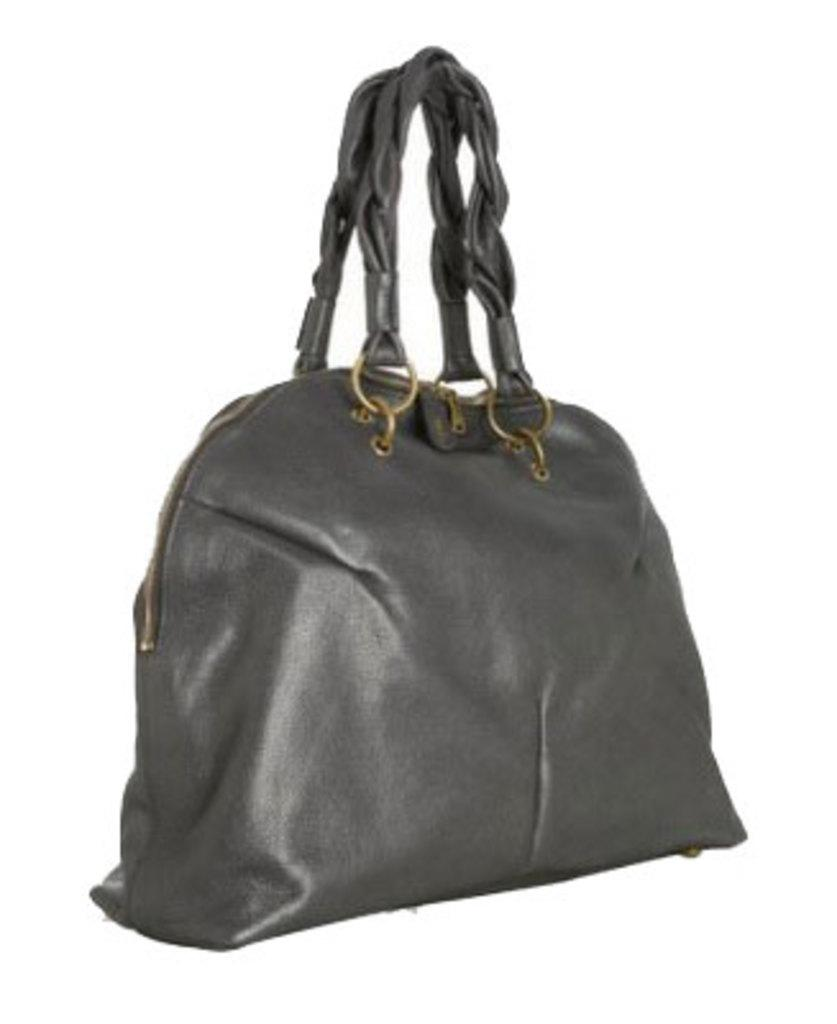What type of handbag is visible in the image? There is a black color handbag in the image. What type of insect can be seen crawling on the cemetery in the image? There is no cemetery or insect present in the image; it only features a black color handbag. 